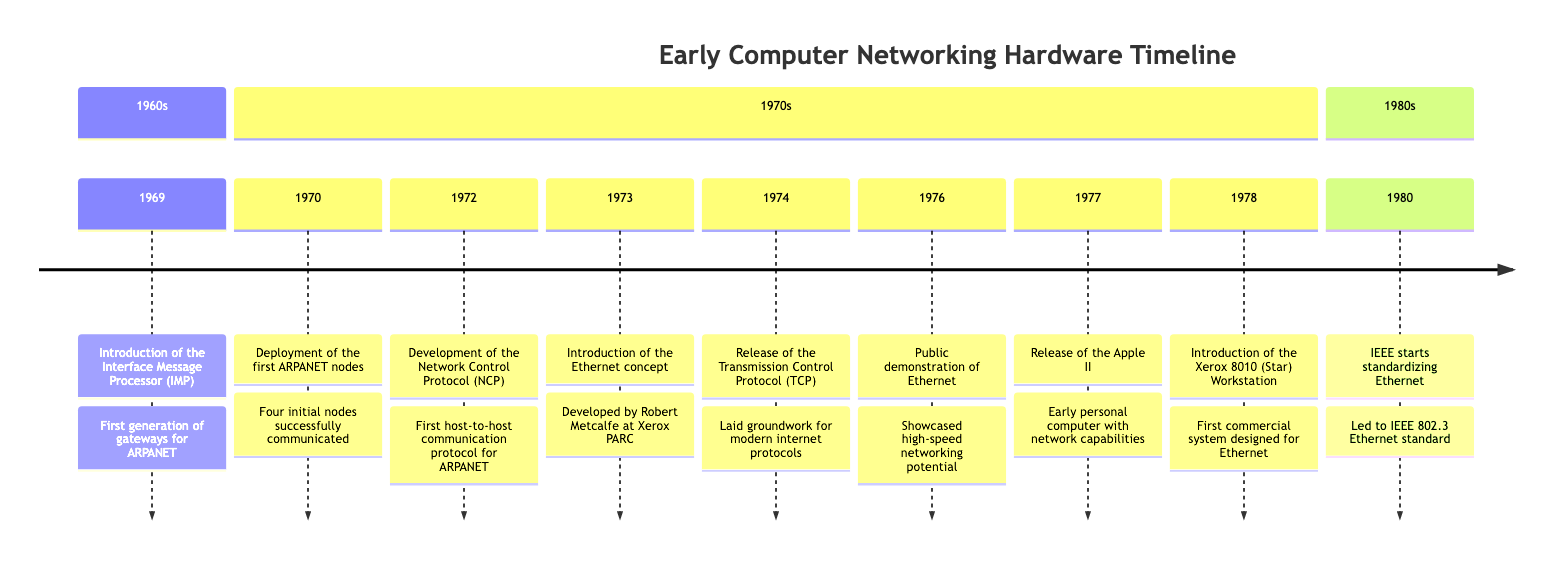What year was the Interface Message Processor introduced? The diagram indicates that the Interface Message Processor (IMP) was introduced in 1969. This can be directly found in the timeline where the event is listed.
Answer: 1969 How many initial ARPANET nodes were deployed in 1970? The timeline states that four initial nodes were deployed in 1970, which can be verified by reading the accompanying description of the event on that year.
Answer: Four What protocol was introduced in 1974? By referring to the 1974 section of the timeline, the event states that the Transmission Control Protocol (TCP) was released. This identifies the specific protocol introduced in that year.
Answer: Transmission Control Protocol (TCP) Which workstation introduced in 1978 was designed to use Ethernet? The description under the 1978 entry mentions the Xerox 8010 (Star) Workstation was the first commercial system designed for use with Ethernet. This is a direct detail from the timeline.
Answer: Xerox 8010 (Star) Workstation What major development in networking occurred in 1973? The timeline details that in 1973, the concept of Ethernet was introduced by Robert Metcalfe. This is the major development referenced and is clearly stated.
Answer: Ethernet Which organization began standardizing Ethernet in 1980? According to the last entry in the timeline for 1980, the IEEE started the standardization process for Ethernet, making it clear who was responsible for this action.
Answer: IEEE What significant demonstration took place in 1976? The 1976 entry describes a public demonstration of Ethernet, showcasing its potential. This information directly answers the question regarding notable events of that year.
Answer: Public demonstration of Ethernet What was the impact of the Apple II released in 1977? The timeline identifies the Apple II as an early personal computer with built-in networking capabilities. This explains its relevance and impact within the context of networking hardware developments.
Answer: Early personal computer with network capabilities In what year did the Network Control Protocol (NCP) become developed? The timeline indicates that NCP was developed in 1972. This information can be easily identified within the respective year’s entry on the timeline.
Answer: 1972 